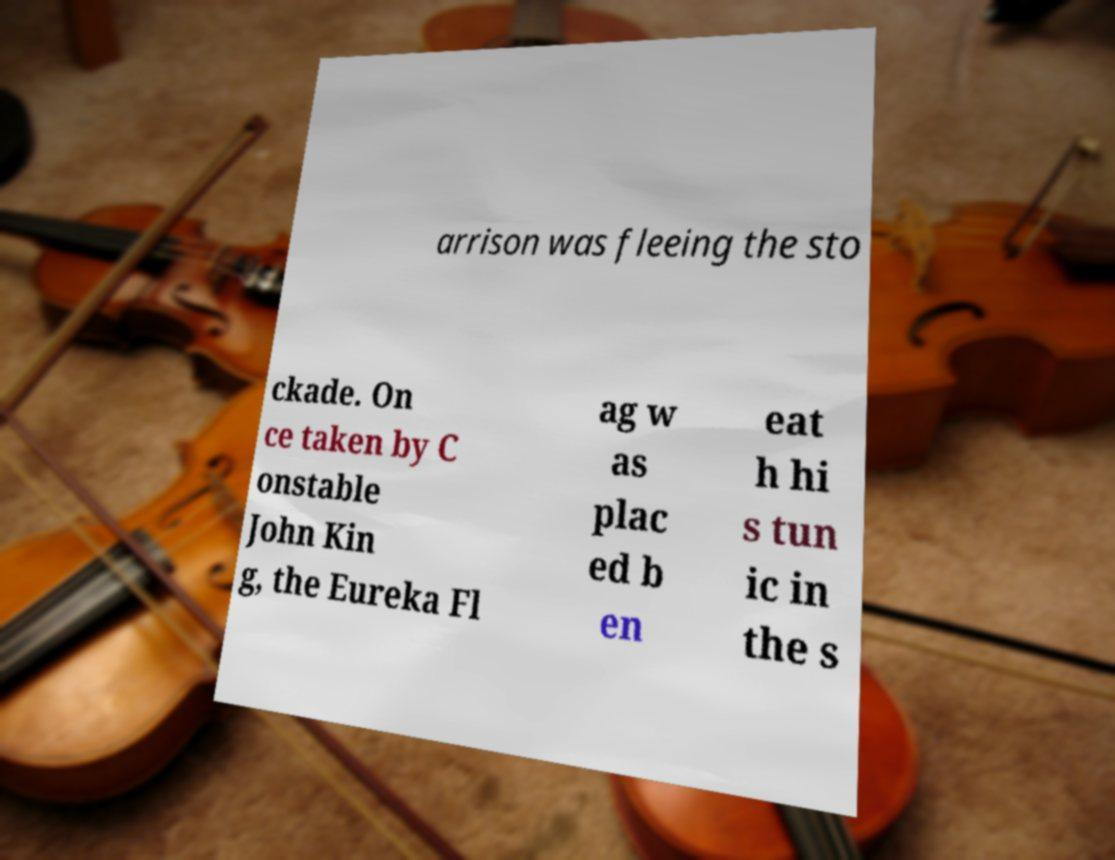What messages or text are displayed in this image? I need them in a readable, typed format. arrison was fleeing the sto ckade. On ce taken by C onstable John Kin g, the Eureka Fl ag w as plac ed b en eat h hi s tun ic in the s 